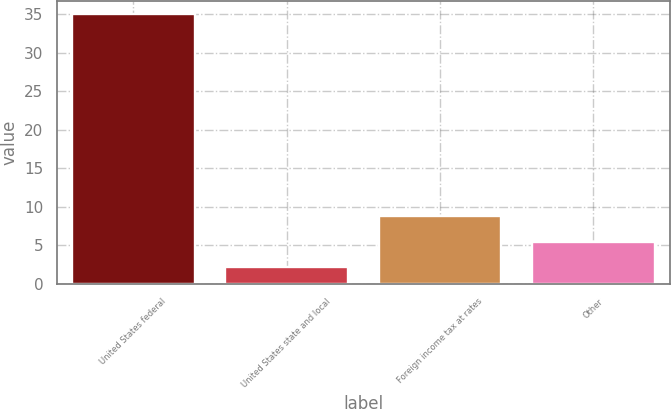Convert chart to OTSL. <chart><loc_0><loc_0><loc_500><loc_500><bar_chart><fcel>United States federal<fcel>United States state and local<fcel>Foreign income tax at rates<fcel>Other<nl><fcel>35<fcel>2.2<fcel>8.76<fcel>5.48<nl></chart> 